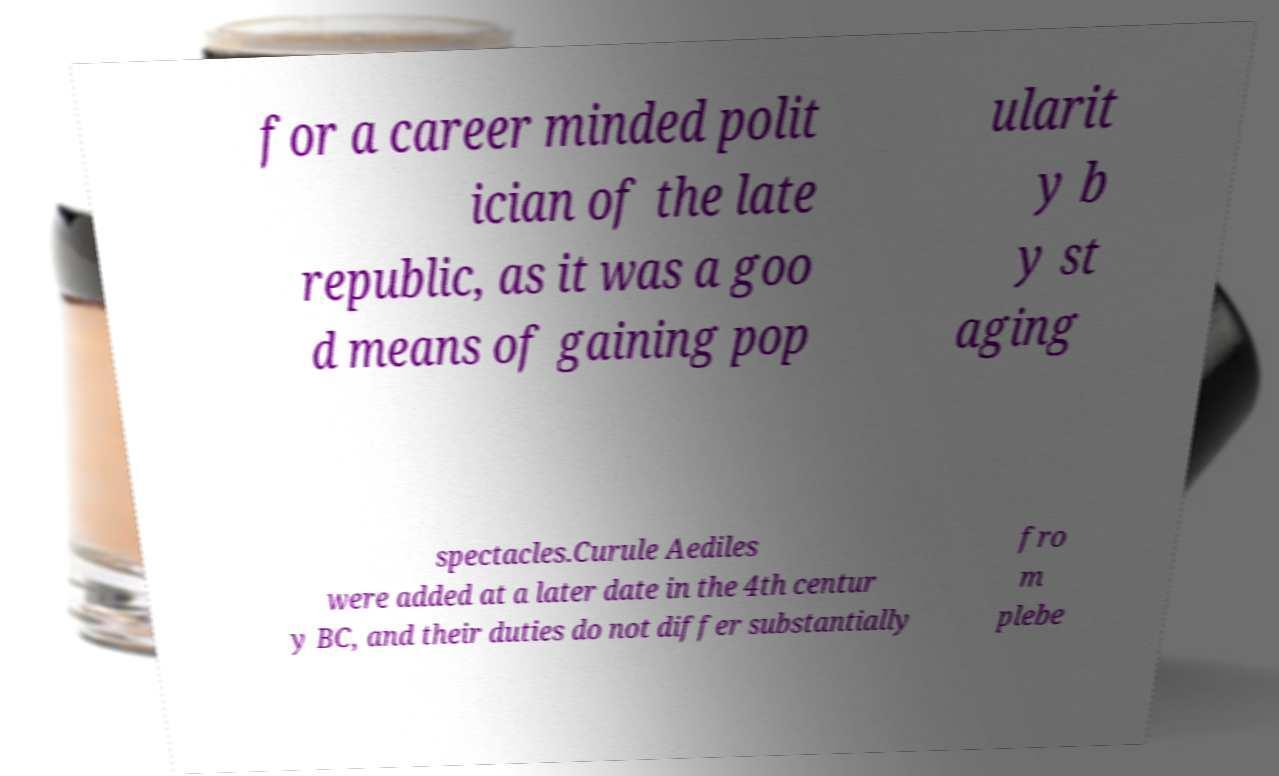Please identify and transcribe the text found in this image. for a career minded polit ician of the late republic, as it was a goo d means of gaining pop ularit y b y st aging spectacles.Curule Aediles were added at a later date in the 4th centur y BC, and their duties do not differ substantially fro m plebe 